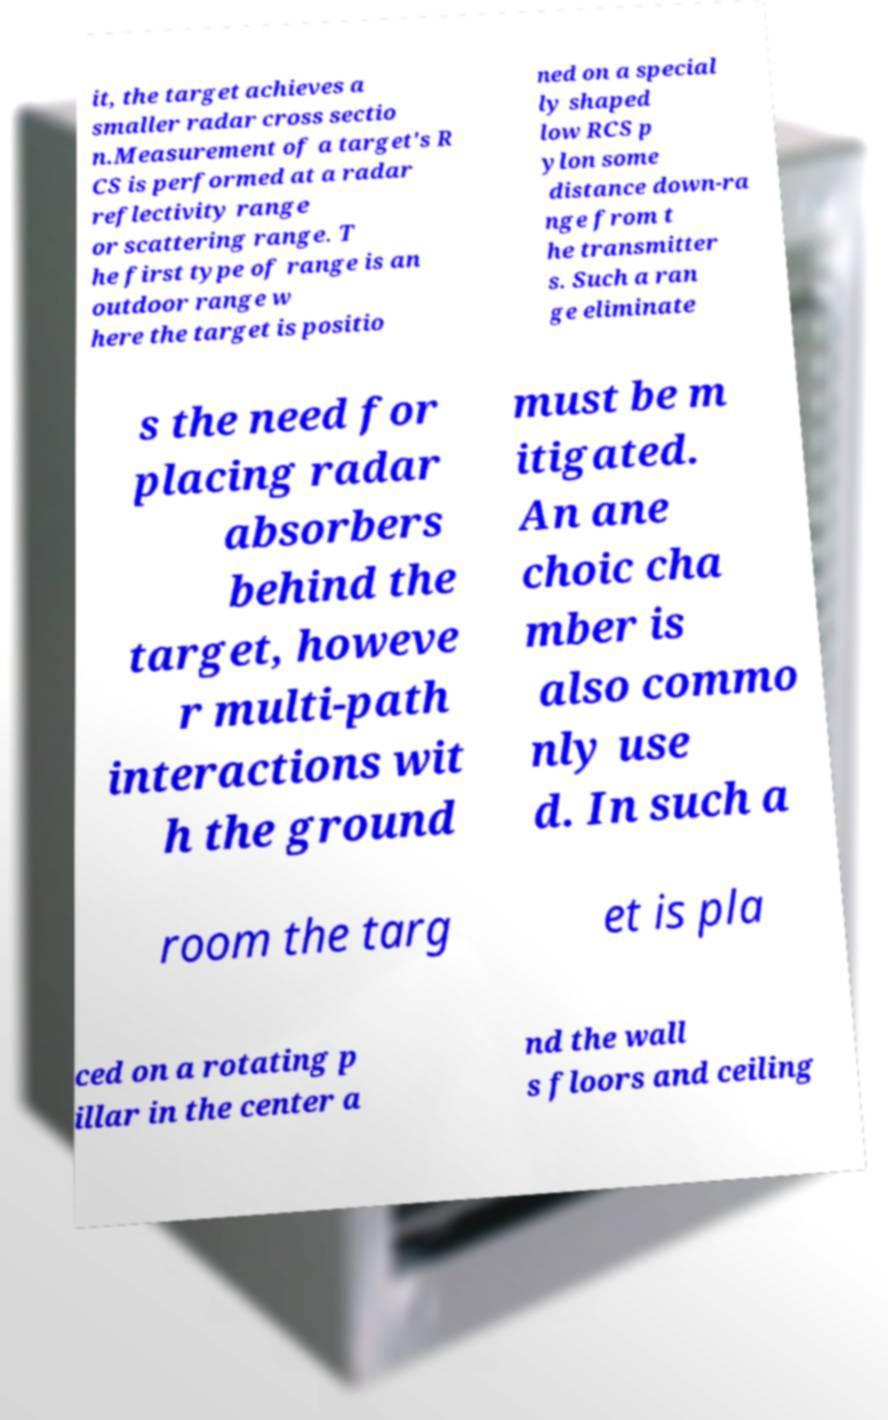There's text embedded in this image that I need extracted. Can you transcribe it verbatim? it, the target achieves a smaller radar cross sectio n.Measurement of a target's R CS is performed at a radar reflectivity range or scattering range. T he first type of range is an outdoor range w here the target is positio ned on a special ly shaped low RCS p ylon some distance down-ra nge from t he transmitter s. Such a ran ge eliminate s the need for placing radar absorbers behind the target, howeve r multi-path interactions wit h the ground must be m itigated. An ane choic cha mber is also commo nly use d. In such a room the targ et is pla ced on a rotating p illar in the center a nd the wall s floors and ceiling 